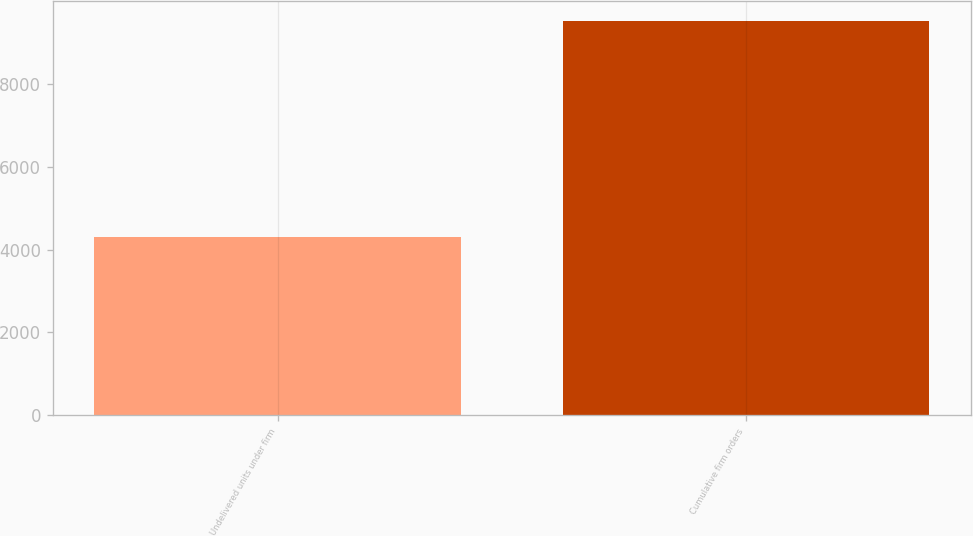<chart> <loc_0><loc_0><loc_500><loc_500><bar_chart><fcel>Undelivered units under firm<fcel>Cumulative firm orders<nl><fcel>4299<fcel>9517<nl></chart> 